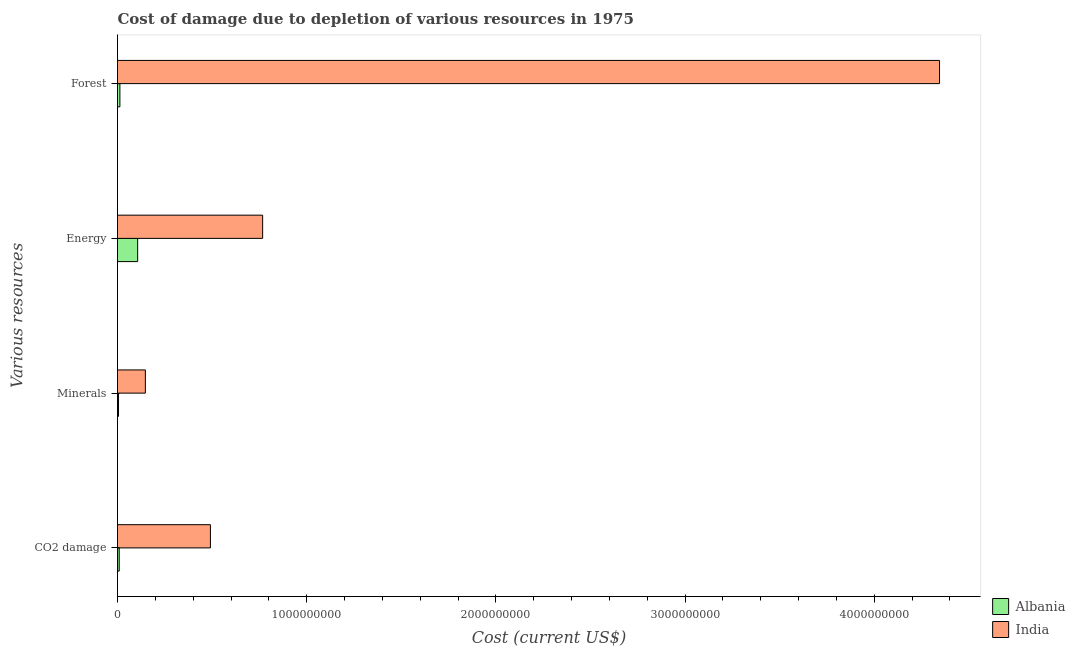How many different coloured bars are there?
Your response must be concise. 2. Are the number of bars on each tick of the Y-axis equal?
Your response must be concise. Yes. How many bars are there on the 2nd tick from the top?
Ensure brevity in your answer.  2. What is the label of the 3rd group of bars from the top?
Your answer should be compact. Minerals. What is the cost of damage due to depletion of forests in India?
Provide a short and direct response. 4.35e+09. Across all countries, what is the maximum cost of damage due to depletion of energy?
Provide a succinct answer. 7.67e+08. Across all countries, what is the minimum cost of damage due to depletion of energy?
Your answer should be compact. 1.06e+08. In which country was the cost of damage due to depletion of minerals maximum?
Make the answer very short. India. In which country was the cost of damage due to depletion of forests minimum?
Offer a very short reply. Albania. What is the total cost of damage due to depletion of energy in the graph?
Provide a succinct answer. 8.74e+08. What is the difference between the cost of damage due to depletion of minerals in India and that in Albania?
Offer a very short reply. 1.42e+08. What is the difference between the cost of damage due to depletion of minerals in India and the cost of damage due to depletion of coal in Albania?
Ensure brevity in your answer.  1.38e+08. What is the average cost of damage due to depletion of energy per country?
Keep it short and to the point. 4.37e+08. What is the difference between the cost of damage due to depletion of coal and cost of damage due to depletion of energy in India?
Ensure brevity in your answer.  -2.76e+08. What is the ratio of the cost of damage due to depletion of coal in India to that in Albania?
Provide a short and direct response. 54.89. Is the cost of damage due to depletion of forests in India less than that in Albania?
Keep it short and to the point. No. Is the difference between the cost of damage due to depletion of energy in India and Albania greater than the difference between the cost of damage due to depletion of forests in India and Albania?
Your response must be concise. No. What is the difference between the highest and the second highest cost of damage due to depletion of forests?
Your answer should be compact. 4.33e+09. What is the difference between the highest and the lowest cost of damage due to depletion of energy?
Provide a succinct answer. 6.61e+08. In how many countries, is the cost of damage due to depletion of forests greater than the average cost of damage due to depletion of forests taken over all countries?
Make the answer very short. 1. Is the sum of the cost of damage due to depletion of energy in India and Albania greater than the maximum cost of damage due to depletion of coal across all countries?
Give a very brief answer. Yes. Is it the case that in every country, the sum of the cost of damage due to depletion of forests and cost of damage due to depletion of minerals is greater than the sum of cost of damage due to depletion of coal and cost of damage due to depletion of energy?
Make the answer very short. No. What does the 2nd bar from the top in Energy represents?
Keep it short and to the point. Albania. What does the 1st bar from the bottom in CO2 damage represents?
Ensure brevity in your answer.  Albania. Is it the case that in every country, the sum of the cost of damage due to depletion of coal and cost of damage due to depletion of minerals is greater than the cost of damage due to depletion of energy?
Make the answer very short. No. How many bars are there?
Give a very brief answer. 8. Are all the bars in the graph horizontal?
Your answer should be compact. Yes. How many countries are there in the graph?
Your answer should be compact. 2. What is the difference between two consecutive major ticks on the X-axis?
Your answer should be compact. 1.00e+09. Are the values on the major ticks of X-axis written in scientific E-notation?
Make the answer very short. No. Does the graph contain any zero values?
Ensure brevity in your answer.  No. How many legend labels are there?
Ensure brevity in your answer.  2. What is the title of the graph?
Provide a succinct answer. Cost of damage due to depletion of various resources in 1975 . What is the label or title of the X-axis?
Offer a very short reply. Cost (current US$). What is the label or title of the Y-axis?
Provide a succinct answer. Various resources. What is the Cost (current US$) in Albania in CO2 damage?
Offer a very short reply. 8.95e+06. What is the Cost (current US$) of India in CO2 damage?
Offer a very short reply. 4.91e+08. What is the Cost (current US$) in Albania in Minerals?
Make the answer very short. 5.34e+06. What is the Cost (current US$) in India in Minerals?
Give a very brief answer. 1.47e+08. What is the Cost (current US$) in Albania in Energy?
Make the answer very short. 1.06e+08. What is the Cost (current US$) in India in Energy?
Your answer should be very brief. 7.67e+08. What is the Cost (current US$) in Albania in Forest?
Offer a terse response. 1.26e+07. What is the Cost (current US$) of India in Forest?
Give a very brief answer. 4.35e+09. Across all Various resources, what is the maximum Cost (current US$) in Albania?
Make the answer very short. 1.06e+08. Across all Various resources, what is the maximum Cost (current US$) in India?
Provide a succinct answer. 4.35e+09. Across all Various resources, what is the minimum Cost (current US$) of Albania?
Give a very brief answer. 5.34e+06. Across all Various resources, what is the minimum Cost (current US$) of India?
Provide a succinct answer. 1.47e+08. What is the total Cost (current US$) of Albania in the graph?
Your answer should be very brief. 1.33e+08. What is the total Cost (current US$) of India in the graph?
Ensure brevity in your answer.  5.75e+09. What is the difference between the Cost (current US$) of Albania in CO2 damage and that in Minerals?
Provide a short and direct response. 3.61e+06. What is the difference between the Cost (current US$) in India in CO2 damage and that in Minerals?
Your response must be concise. 3.44e+08. What is the difference between the Cost (current US$) in Albania in CO2 damage and that in Energy?
Your response must be concise. -9.75e+07. What is the difference between the Cost (current US$) in India in CO2 damage and that in Energy?
Your answer should be very brief. -2.76e+08. What is the difference between the Cost (current US$) in Albania in CO2 damage and that in Forest?
Your response must be concise. -3.70e+06. What is the difference between the Cost (current US$) of India in CO2 damage and that in Forest?
Provide a succinct answer. -3.85e+09. What is the difference between the Cost (current US$) in Albania in Minerals and that in Energy?
Your answer should be compact. -1.01e+08. What is the difference between the Cost (current US$) in India in Minerals and that in Energy?
Your answer should be compact. -6.20e+08. What is the difference between the Cost (current US$) in Albania in Minerals and that in Forest?
Offer a very short reply. -7.31e+06. What is the difference between the Cost (current US$) of India in Minerals and that in Forest?
Your response must be concise. -4.20e+09. What is the difference between the Cost (current US$) of Albania in Energy and that in Forest?
Give a very brief answer. 9.38e+07. What is the difference between the Cost (current US$) of India in Energy and that in Forest?
Offer a very short reply. -3.58e+09. What is the difference between the Cost (current US$) of Albania in CO2 damage and the Cost (current US$) of India in Minerals?
Your response must be concise. -1.38e+08. What is the difference between the Cost (current US$) in Albania in CO2 damage and the Cost (current US$) in India in Energy?
Provide a short and direct response. -7.58e+08. What is the difference between the Cost (current US$) in Albania in CO2 damage and the Cost (current US$) in India in Forest?
Give a very brief answer. -4.34e+09. What is the difference between the Cost (current US$) in Albania in Minerals and the Cost (current US$) in India in Energy?
Give a very brief answer. -7.62e+08. What is the difference between the Cost (current US$) in Albania in Minerals and the Cost (current US$) in India in Forest?
Keep it short and to the point. -4.34e+09. What is the difference between the Cost (current US$) in Albania in Energy and the Cost (current US$) in India in Forest?
Ensure brevity in your answer.  -4.24e+09. What is the average Cost (current US$) of Albania per Various resources?
Make the answer very short. 3.34e+07. What is the average Cost (current US$) in India per Various resources?
Provide a succinct answer. 1.44e+09. What is the difference between the Cost (current US$) in Albania and Cost (current US$) in India in CO2 damage?
Provide a short and direct response. -4.82e+08. What is the difference between the Cost (current US$) of Albania and Cost (current US$) of India in Minerals?
Provide a succinct answer. -1.42e+08. What is the difference between the Cost (current US$) in Albania and Cost (current US$) in India in Energy?
Give a very brief answer. -6.61e+08. What is the difference between the Cost (current US$) of Albania and Cost (current US$) of India in Forest?
Make the answer very short. -4.33e+09. What is the ratio of the Cost (current US$) of Albania in CO2 damage to that in Minerals?
Ensure brevity in your answer.  1.68. What is the ratio of the Cost (current US$) of India in CO2 damage to that in Minerals?
Your answer should be compact. 3.33. What is the ratio of the Cost (current US$) of Albania in CO2 damage to that in Energy?
Give a very brief answer. 0.08. What is the ratio of the Cost (current US$) of India in CO2 damage to that in Energy?
Offer a very short reply. 0.64. What is the ratio of the Cost (current US$) of Albania in CO2 damage to that in Forest?
Give a very brief answer. 0.71. What is the ratio of the Cost (current US$) in India in CO2 damage to that in Forest?
Offer a very short reply. 0.11. What is the ratio of the Cost (current US$) in Albania in Minerals to that in Energy?
Make the answer very short. 0.05. What is the ratio of the Cost (current US$) in India in Minerals to that in Energy?
Give a very brief answer. 0.19. What is the ratio of the Cost (current US$) of Albania in Minerals to that in Forest?
Your answer should be very brief. 0.42. What is the ratio of the Cost (current US$) of India in Minerals to that in Forest?
Your response must be concise. 0.03. What is the ratio of the Cost (current US$) of Albania in Energy to that in Forest?
Your answer should be very brief. 8.42. What is the ratio of the Cost (current US$) in India in Energy to that in Forest?
Offer a terse response. 0.18. What is the difference between the highest and the second highest Cost (current US$) in Albania?
Your answer should be very brief. 9.38e+07. What is the difference between the highest and the second highest Cost (current US$) in India?
Ensure brevity in your answer.  3.58e+09. What is the difference between the highest and the lowest Cost (current US$) of Albania?
Provide a short and direct response. 1.01e+08. What is the difference between the highest and the lowest Cost (current US$) of India?
Offer a very short reply. 4.20e+09. 